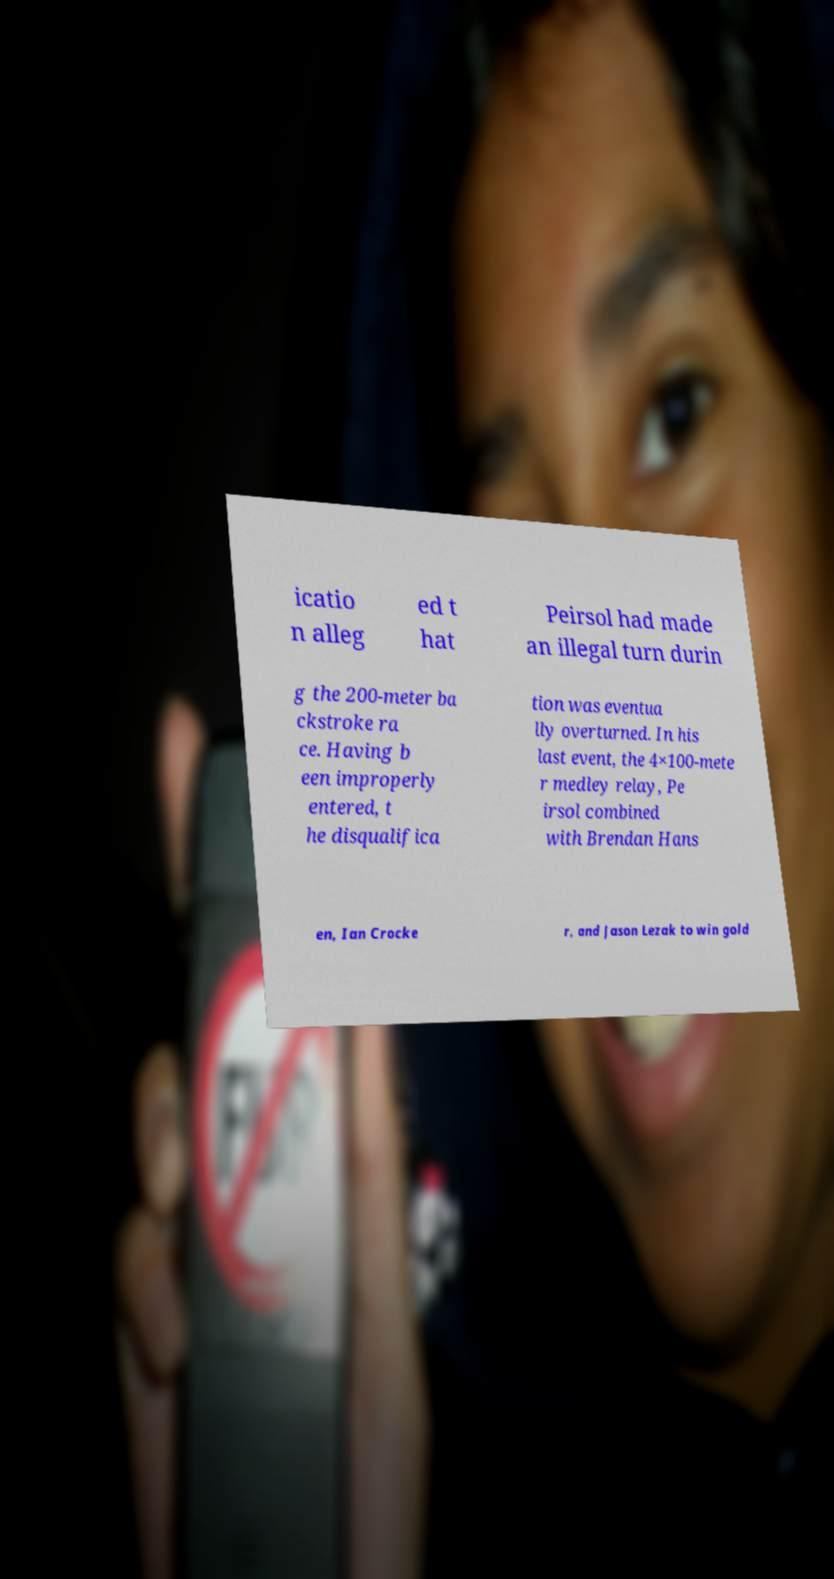Could you extract and type out the text from this image? icatio n alleg ed t hat Peirsol had made an illegal turn durin g the 200-meter ba ckstroke ra ce. Having b een improperly entered, t he disqualifica tion was eventua lly overturned. In his last event, the 4×100-mete r medley relay, Pe irsol combined with Brendan Hans en, Ian Crocke r, and Jason Lezak to win gold 